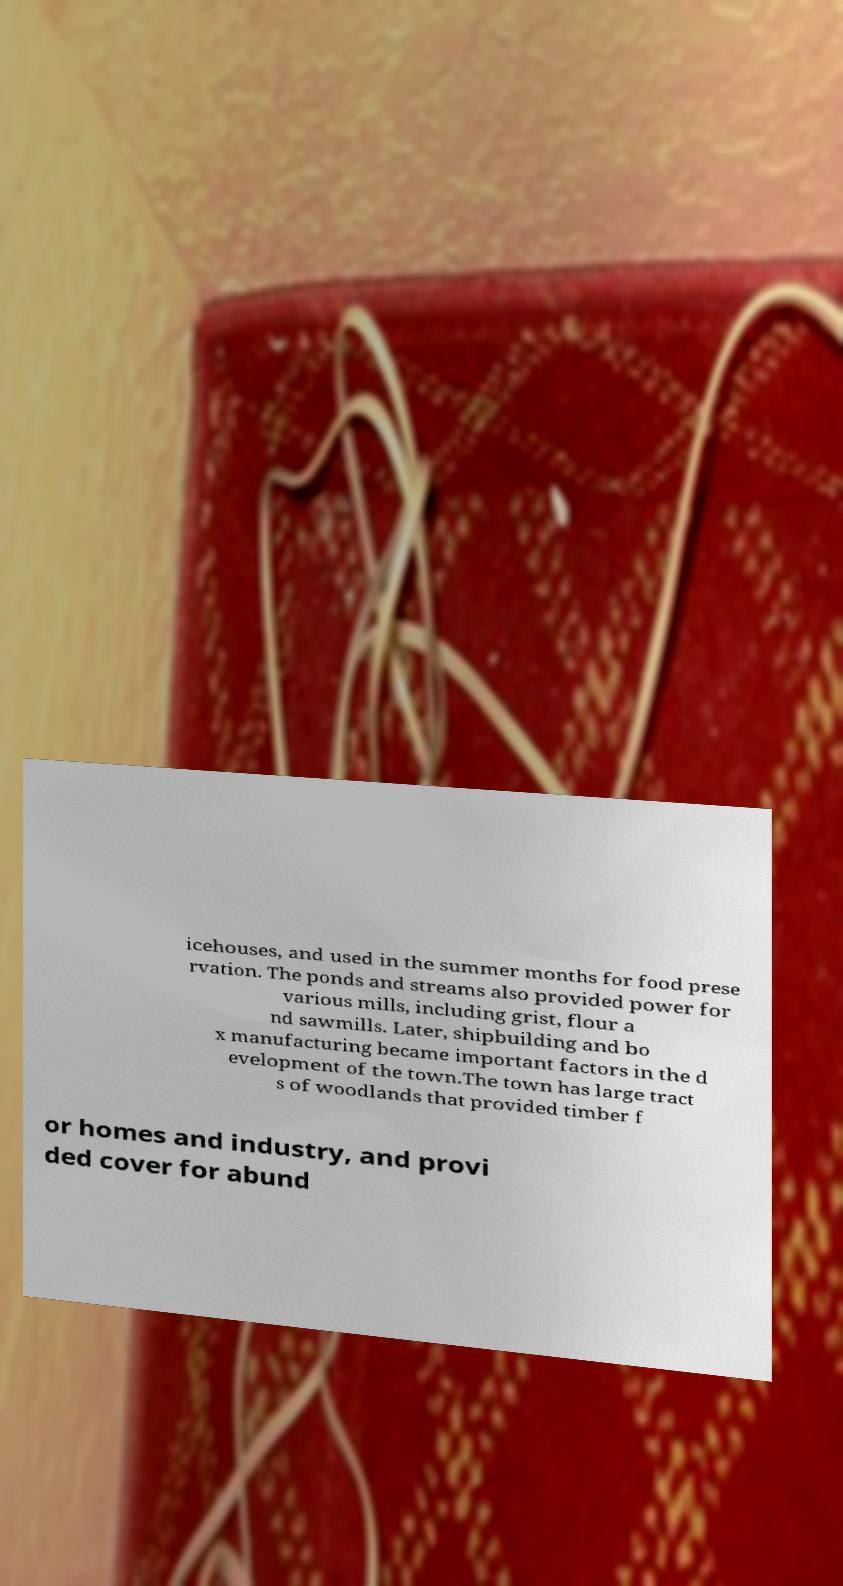What messages or text are displayed in this image? I need them in a readable, typed format. icehouses, and used in the summer months for food prese rvation. The ponds and streams also provided power for various mills, including grist, flour a nd sawmills. Later, shipbuilding and bo x manufacturing became important factors in the d evelopment of the town.The town has large tract s of woodlands that provided timber f or homes and industry, and provi ded cover for abund 